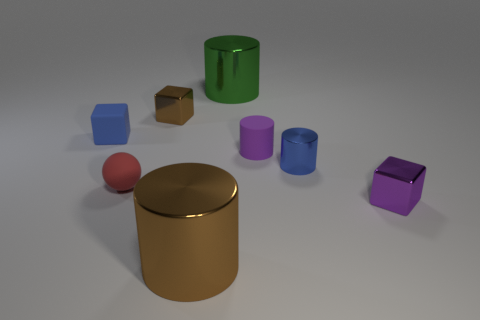Subtract all shiny cubes. How many cubes are left? 1 Subtract all green cylinders. How many cylinders are left? 3 Subtract all balls. How many objects are left? 7 Subtract 1 blocks. How many blocks are left? 2 Add 1 shiny objects. How many objects exist? 9 Subtract all green cylinders. Subtract all blue spheres. How many cylinders are left? 3 Subtract all big brown metal objects. Subtract all purple shiny balls. How many objects are left? 7 Add 7 big brown cylinders. How many big brown cylinders are left? 8 Add 1 red rubber things. How many red rubber things exist? 2 Subtract 0 red cylinders. How many objects are left? 8 